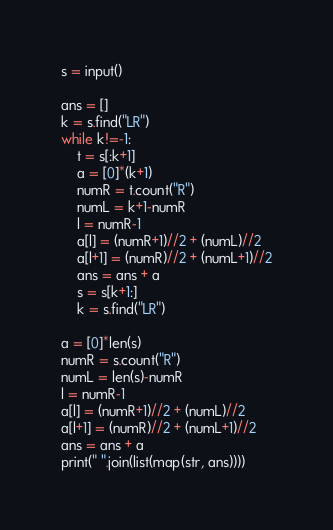Convert code to text. <code><loc_0><loc_0><loc_500><loc_500><_Python_>s = input()

ans = []
k = s.find("LR")
while k!=-1:
    t = s[:k+1]
    a = [0]*(k+1)
    numR = t.count("R")
    numL = k+1-numR
    l = numR-1
    a[l] = (numR+1)//2 + (numL)//2
    a[l+1] = (numR)//2 + (numL+1)//2
    ans = ans + a
    s = s[k+1:]
    k = s.find("LR")

a = [0]*len(s)
numR = s.count("R")
numL = len(s)-numR
l = numR-1
a[l] = (numR+1)//2 + (numL)//2
a[l+1] = (numR)//2 + (numL+1)//2
ans = ans + a
print(" ".join(list(map(str, ans))))</code> 